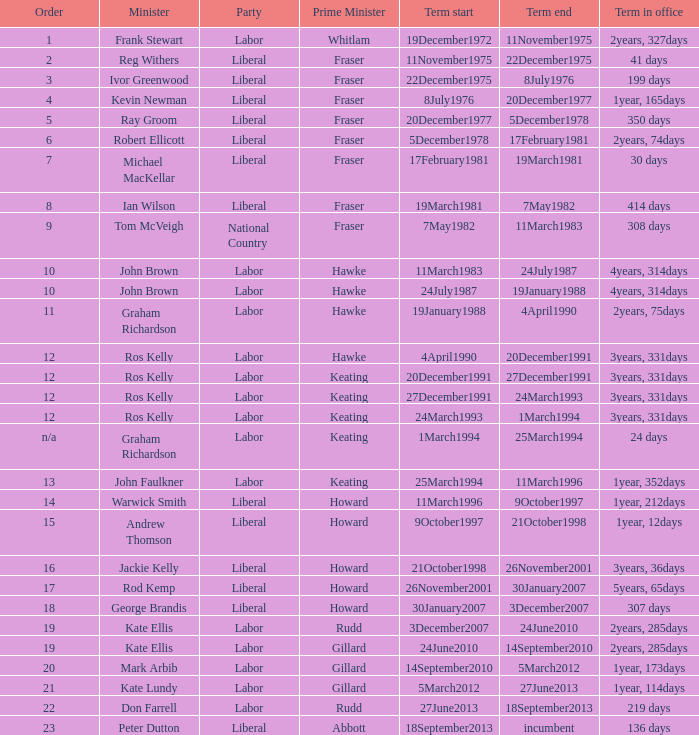Could you parse the entire table? {'header': ['Order', 'Minister', 'Party', 'Prime Minister', 'Term start', 'Term end', 'Term in office'], 'rows': [['1', 'Frank Stewart', 'Labor', 'Whitlam', '19December1972', '11November1975', '2years, 327days'], ['2', 'Reg Withers', 'Liberal', 'Fraser', '11November1975', '22December1975', '41 days'], ['3', 'Ivor Greenwood', 'Liberal', 'Fraser', '22December1975', '8July1976', '199 days'], ['4', 'Kevin Newman', 'Liberal', 'Fraser', '8July1976', '20December1977', '1year, 165days'], ['5', 'Ray Groom', 'Liberal', 'Fraser', '20December1977', '5December1978', '350 days'], ['6', 'Robert Ellicott', 'Liberal', 'Fraser', '5December1978', '17February1981', '2years, 74days'], ['7', 'Michael MacKellar', 'Liberal', 'Fraser', '17February1981', '19March1981', '30 days'], ['8', 'Ian Wilson', 'Liberal', 'Fraser', '19March1981', '7May1982', '414 days'], ['9', 'Tom McVeigh', 'National Country', 'Fraser', '7May1982', '11March1983', '308 days'], ['10', 'John Brown', 'Labor', 'Hawke', '11March1983', '24July1987', '4years, 314days'], ['10', 'John Brown', 'Labor', 'Hawke', '24July1987', '19January1988', '4years, 314days'], ['11', 'Graham Richardson', 'Labor', 'Hawke', '19January1988', '4April1990', '2years, 75days'], ['12', 'Ros Kelly', 'Labor', 'Hawke', '4April1990', '20December1991', '3years, 331days'], ['12', 'Ros Kelly', 'Labor', 'Keating', '20December1991', '27December1991', '3years, 331days'], ['12', 'Ros Kelly', 'Labor', 'Keating', '27December1991', '24March1993', '3years, 331days'], ['12', 'Ros Kelly', 'Labor', 'Keating', '24March1993', '1March1994', '3years, 331days'], ['n/a', 'Graham Richardson', 'Labor', 'Keating', '1March1994', '25March1994', '24 days'], ['13', 'John Faulkner', 'Labor', 'Keating', '25March1994', '11March1996', '1year, 352days'], ['14', 'Warwick Smith', 'Liberal', 'Howard', '11March1996', '9October1997', '1year, 212days'], ['15', 'Andrew Thomson', 'Liberal', 'Howard', '9October1997', '21October1998', '1year, 12days'], ['16', 'Jackie Kelly', 'Liberal', 'Howard', '21October1998', '26November2001', '3years, 36days'], ['17', 'Rod Kemp', 'Liberal', 'Howard', '26November2001', '30January2007', '5years, 65days'], ['18', 'George Brandis', 'Liberal', 'Howard', '30January2007', '3December2007', '307 days'], ['19', 'Kate Ellis', 'Labor', 'Rudd', '3December2007', '24June2010', '2years, 285days'], ['19', 'Kate Ellis', 'Labor', 'Gillard', '24June2010', '14September2010', '2years, 285days'], ['20', 'Mark Arbib', 'Labor', 'Gillard', '14September2010', '5March2012', '1year, 173days'], ['21', 'Kate Lundy', 'Labor', 'Gillard', '5March2012', '27June2013', '1year, 114days'], ['22', 'Don Farrell', 'Labor', 'Rudd', '27June2013', '18September2013', '219 days'], ['23', 'Peter Dutton', 'Liberal', 'Abbott', '18September2013', 'incumbent', '136 days']]} What is the Term in office with an Order that is 9? 308 days. 